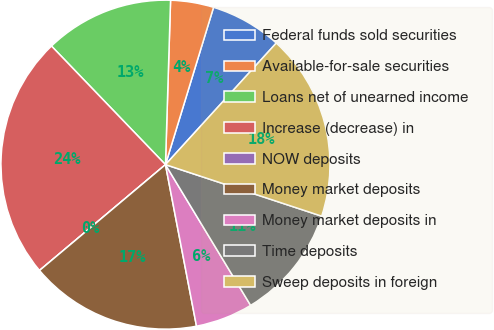<chart> <loc_0><loc_0><loc_500><loc_500><pie_chart><fcel>Federal funds sold securities<fcel>Available-for-sale securities<fcel>Loans net of unearned income<fcel>Increase (decrease) in<fcel>NOW deposits<fcel>Money market deposits<fcel>Money market deposits in<fcel>Time deposits<fcel>Sweep deposits in foreign<nl><fcel>7.04%<fcel>4.23%<fcel>12.68%<fcel>23.94%<fcel>0.0%<fcel>16.9%<fcel>5.64%<fcel>11.27%<fcel>18.31%<nl></chart> 